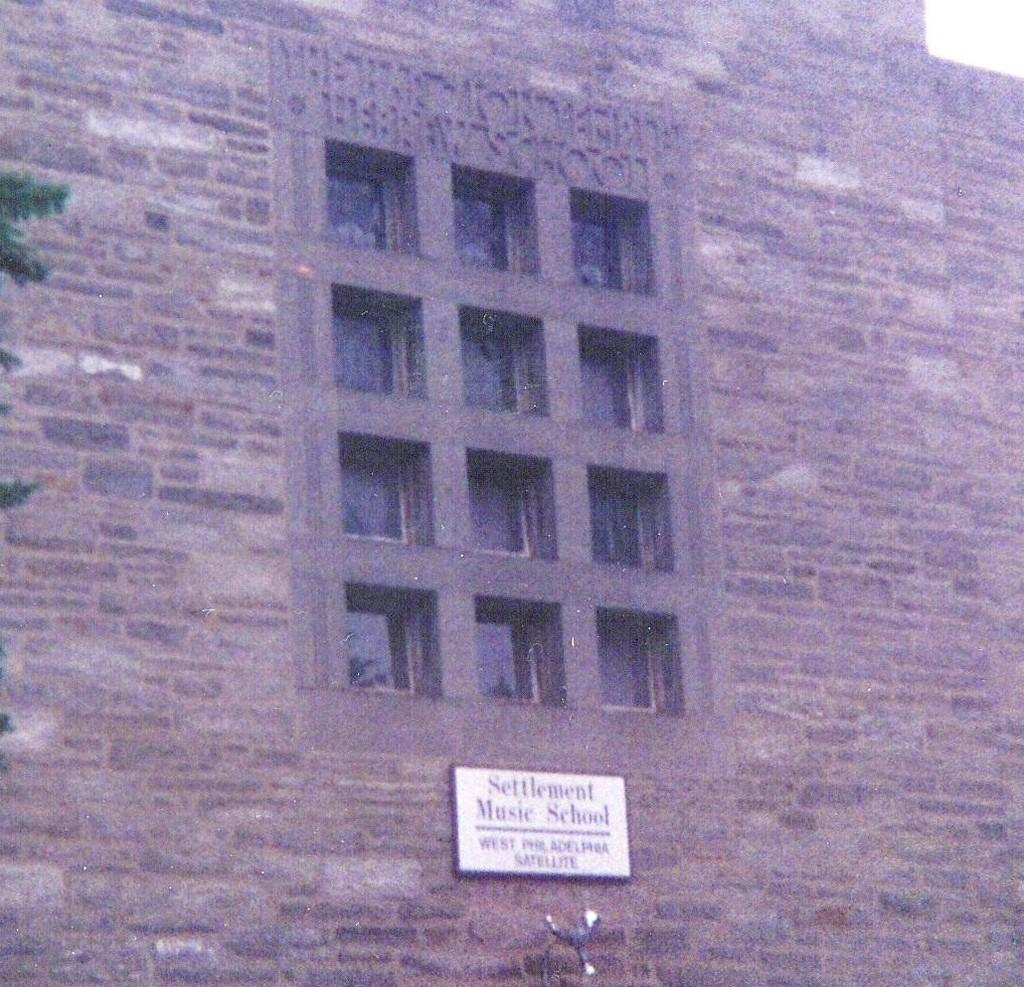What type of structure is visible in the image? There is a building in the image. What feature can be seen on the building? The building has windows. What is located at the bottom of the image? There is a board at the bottom of the image. What type of vegetation is on the left side of the image? There is a tree on the left side of the image. What type of wine is being served at the meal in the image? There is no meal or wine present in the image; it only features a building, windows, a board, and a tree. 